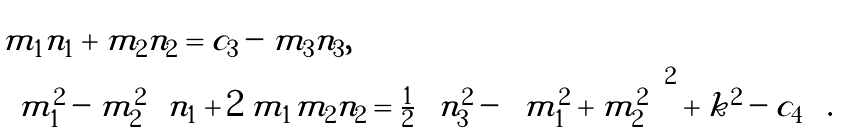Convert formula to latex. <formula><loc_0><loc_0><loc_500><loc_500>\begin{array} { l } m _ { 1 } n _ { 1 } + m _ { 2 } n _ { 2 } = c _ { 3 } - m _ { 3 } n _ { 3 } , \\ \left ( m _ { 1 } ^ { 2 } - m _ { 2 } ^ { 2 } \right ) n _ { 1 } + 2 \, m _ { 1 } m _ { 2 } n _ { 2 } = \frac { 1 } { 2 } \left ( n _ { 3 } ^ { 2 } - \left ( m _ { 1 } ^ { 2 } + m _ { 2 } ^ { 2 } \right ) ^ { 2 } + k ^ { 2 } - c _ { 4 } \right ) . \end{array}</formula> 